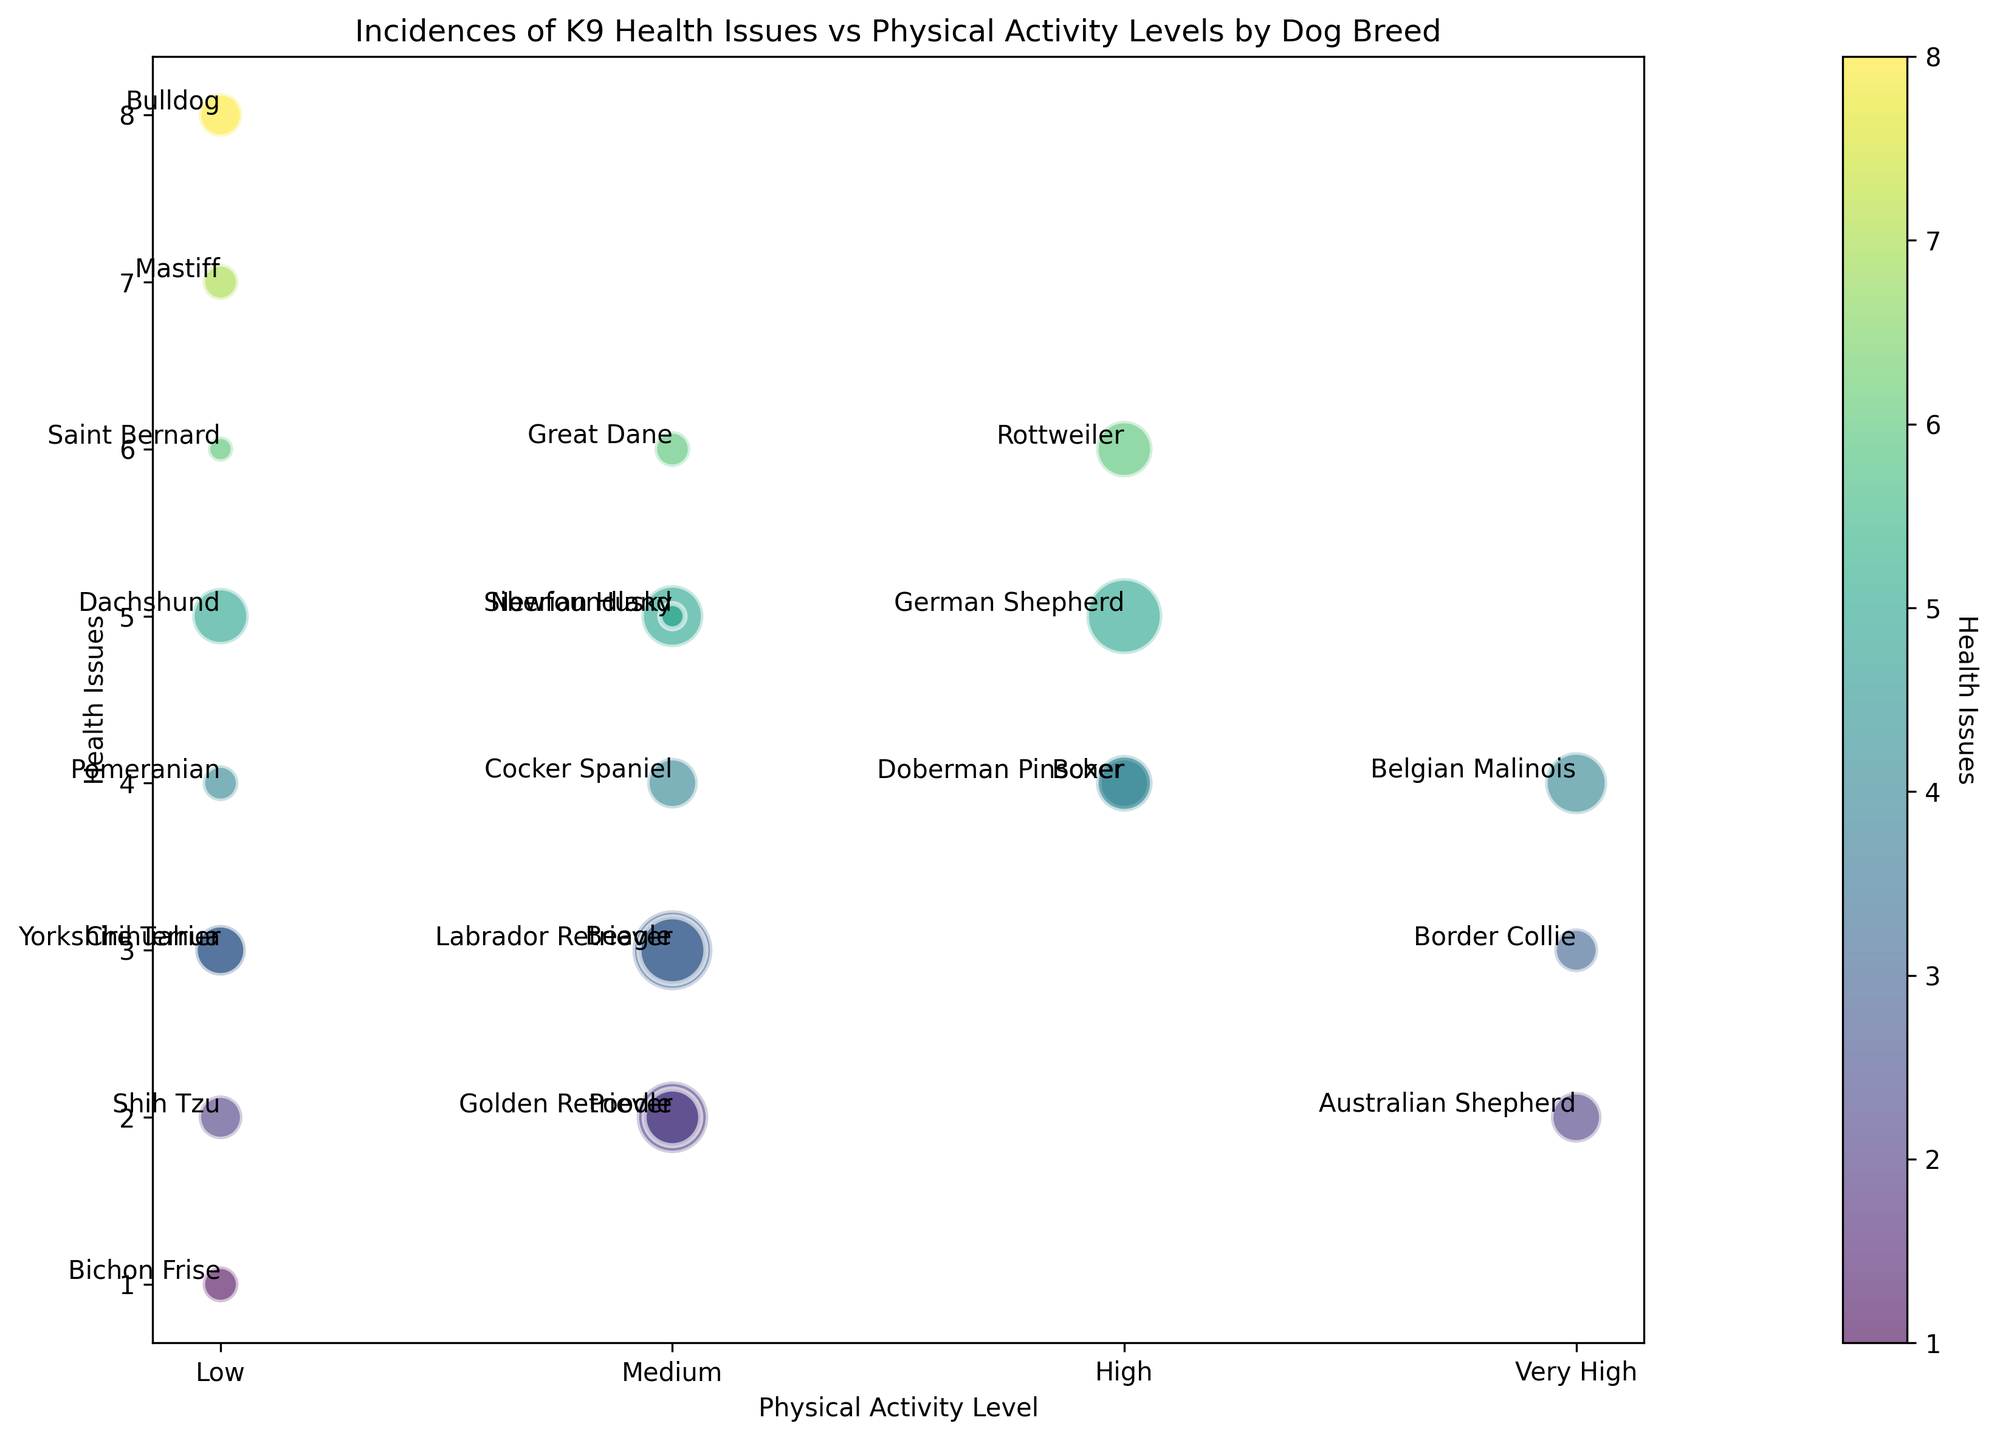Which breed experiences the highest number of health issues? By examining the y-axis values which represent health issues, the breed at the highest point is identified. Bulldog is at health issues level 8.
Answer: Bulldog Are there any breeds with both very high physical activity levels and low health issues? Looking at the x-axis labeled 'Very High' and identifying the breeds, we see that the Australian Shepherd is at a low level of health issues (2).
Answer: Australian Shepherd Which breed with medium physical activity has the highest health issues? Locate the breeds with 'Medium' physical activity on the x-axis and compare their y-axis positions. Great Dane has the highest health issues at 6 among Medium activity breeds.
Answer: Great Dane What are the health issues levels for breeds with low physical activity? Identify all breeds at 'Low' activity level on the x-axis and note their y-axis values: Bulldog (8), Chihuahua (3), Dachshund (5), Mastiff (7), Pomeranian (4), Saint Bernard (6), Shih Tzu (2), and Yorkshire Terrier (3).
Answer: 2, 3, 3, 4, 5, 6, 7, 8 Which breeds have exactly four health issues? Locate the y-axis value of 4 and identify the corresponding breeds by looking at their labels: Boxer, Doberman Pinscher, and Cocker Spaniel.
Answer: Boxer, Doberman Pinscher, Cocker Spaniel How do health issues differ between breeds with high and very high physical activity levels? Compare the y-axis values of breeds with 'High' and 'Very High' activity levels. On 'High': German Shepherd (5), Rottweiler (6), Boxer (4), Doberman Pinscher (4). On 'Very High': Belgian Malinois (4), Border Collie (3), Australian Shepherd (2).
Answer: High: 4, 4, 5, 6; Very High: 2, 3, 4 Which breed with the lowest physical activity has the smallest number of health issues? Identify breeds with 'Low' physical activity and locate the smallest y-axis value: Bichon Frise has 1 health issue.
Answer: Bichon Frise Compare the number of health issues of German Shepherd and Rottweiler. Which one has more? Locate German Shepherd and Rottweiler on the plot. German Shepherd has 5 health issues and Rottweiler has 6. Therefore, Rottweiler has more health issues.
Answer: Rottweiler What is the bubble size difference between Labrador Retriever and Poodle, and what does this difference represent? Compare the bubble sizes for Labrador Retriever and Poodle; Labrador Retriever's bubble is larger. Bubble size represents the number of dogs. Labrador Retriever (50), Poodle (25). The difference is 50 - 25 = 25 dogs.
Answer: 25 dogs Which breed(s) has precisely 5 health issues, and how do their physical activity levels differ? Locate the breeds at the 5-level on the y-axis: German Shepherd (High), Siberian Husky (Medium), Dachshund (Low), Newfoundland (Medium). Their activity levels vary across High, Medium, and Low.
Answer: German Shepherd, Siberian Husky, Dachshund, Newfoundland 